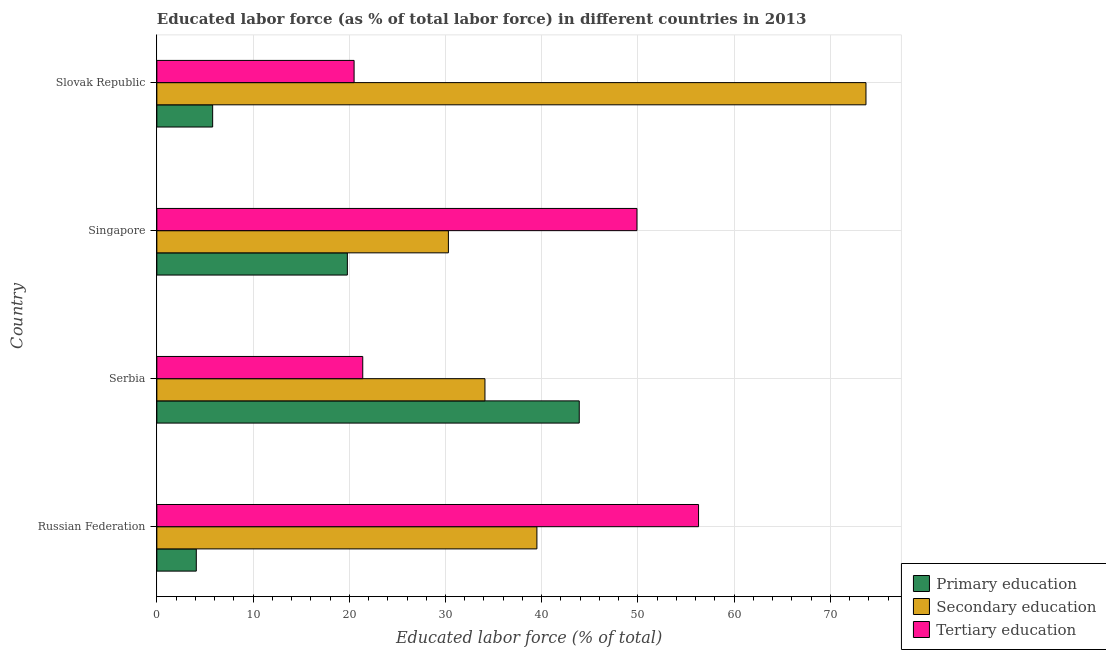How many groups of bars are there?
Provide a short and direct response. 4. How many bars are there on the 4th tick from the bottom?
Provide a succinct answer. 3. What is the label of the 2nd group of bars from the top?
Your answer should be very brief. Singapore. In how many cases, is the number of bars for a given country not equal to the number of legend labels?
Give a very brief answer. 0. What is the percentage of labor force who received primary education in Slovak Republic?
Your answer should be compact. 5.8. Across all countries, what is the maximum percentage of labor force who received tertiary education?
Offer a very short reply. 56.3. In which country was the percentage of labor force who received tertiary education maximum?
Ensure brevity in your answer.  Russian Federation. In which country was the percentage of labor force who received secondary education minimum?
Offer a terse response. Singapore. What is the total percentage of labor force who received primary education in the graph?
Your answer should be very brief. 73.6. What is the difference between the percentage of labor force who received primary education in Russian Federation and that in Serbia?
Keep it short and to the point. -39.8. What is the difference between the percentage of labor force who received primary education in Serbia and the percentage of labor force who received tertiary education in Russian Federation?
Your response must be concise. -12.4. What is the average percentage of labor force who received secondary education per country?
Keep it short and to the point. 44.4. What is the difference between the percentage of labor force who received tertiary education and percentage of labor force who received secondary education in Serbia?
Make the answer very short. -12.7. In how many countries, is the percentage of labor force who received primary education greater than 52 %?
Keep it short and to the point. 0. What is the ratio of the percentage of labor force who received primary education in Serbia to that in Slovak Republic?
Your answer should be very brief. 7.57. What is the difference between the highest and the second highest percentage of labor force who received secondary education?
Give a very brief answer. 34.2. What is the difference between the highest and the lowest percentage of labor force who received secondary education?
Provide a short and direct response. 43.4. Is the sum of the percentage of labor force who received tertiary education in Serbia and Slovak Republic greater than the maximum percentage of labor force who received secondary education across all countries?
Provide a short and direct response. No. What does the 3rd bar from the top in Russian Federation represents?
Provide a short and direct response. Primary education. What does the 2nd bar from the bottom in Singapore represents?
Give a very brief answer. Secondary education. Is it the case that in every country, the sum of the percentage of labor force who received primary education and percentage of labor force who received secondary education is greater than the percentage of labor force who received tertiary education?
Your answer should be very brief. No. How many bars are there?
Your answer should be compact. 12. Are all the bars in the graph horizontal?
Give a very brief answer. Yes. Does the graph contain grids?
Your answer should be compact. Yes. How many legend labels are there?
Provide a short and direct response. 3. What is the title of the graph?
Provide a succinct answer. Educated labor force (as % of total labor force) in different countries in 2013. What is the label or title of the X-axis?
Your response must be concise. Educated labor force (% of total). What is the Educated labor force (% of total) in Primary education in Russian Federation?
Ensure brevity in your answer.  4.1. What is the Educated labor force (% of total) in Secondary education in Russian Federation?
Provide a short and direct response. 39.5. What is the Educated labor force (% of total) in Tertiary education in Russian Federation?
Keep it short and to the point. 56.3. What is the Educated labor force (% of total) in Primary education in Serbia?
Offer a terse response. 43.9. What is the Educated labor force (% of total) of Secondary education in Serbia?
Your answer should be compact. 34.1. What is the Educated labor force (% of total) of Tertiary education in Serbia?
Provide a succinct answer. 21.4. What is the Educated labor force (% of total) of Primary education in Singapore?
Make the answer very short. 19.8. What is the Educated labor force (% of total) in Secondary education in Singapore?
Ensure brevity in your answer.  30.3. What is the Educated labor force (% of total) in Tertiary education in Singapore?
Your response must be concise. 49.9. What is the Educated labor force (% of total) in Primary education in Slovak Republic?
Your response must be concise. 5.8. What is the Educated labor force (% of total) of Secondary education in Slovak Republic?
Ensure brevity in your answer.  73.7. What is the Educated labor force (% of total) of Tertiary education in Slovak Republic?
Provide a succinct answer. 20.5. Across all countries, what is the maximum Educated labor force (% of total) of Primary education?
Make the answer very short. 43.9. Across all countries, what is the maximum Educated labor force (% of total) in Secondary education?
Provide a succinct answer. 73.7. Across all countries, what is the maximum Educated labor force (% of total) in Tertiary education?
Ensure brevity in your answer.  56.3. Across all countries, what is the minimum Educated labor force (% of total) in Primary education?
Keep it short and to the point. 4.1. Across all countries, what is the minimum Educated labor force (% of total) of Secondary education?
Your answer should be very brief. 30.3. Across all countries, what is the minimum Educated labor force (% of total) of Tertiary education?
Keep it short and to the point. 20.5. What is the total Educated labor force (% of total) of Primary education in the graph?
Your answer should be very brief. 73.6. What is the total Educated labor force (% of total) of Secondary education in the graph?
Your answer should be very brief. 177.6. What is the total Educated labor force (% of total) in Tertiary education in the graph?
Provide a short and direct response. 148.1. What is the difference between the Educated labor force (% of total) of Primary education in Russian Federation and that in Serbia?
Ensure brevity in your answer.  -39.8. What is the difference between the Educated labor force (% of total) of Secondary education in Russian Federation and that in Serbia?
Your response must be concise. 5.4. What is the difference between the Educated labor force (% of total) in Tertiary education in Russian Federation and that in Serbia?
Offer a very short reply. 34.9. What is the difference between the Educated labor force (% of total) in Primary education in Russian Federation and that in Singapore?
Your response must be concise. -15.7. What is the difference between the Educated labor force (% of total) in Secondary education in Russian Federation and that in Singapore?
Ensure brevity in your answer.  9.2. What is the difference between the Educated labor force (% of total) in Primary education in Russian Federation and that in Slovak Republic?
Give a very brief answer. -1.7. What is the difference between the Educated labor force (% of total) of Secondary education in Russian Federation and that in Slovak Republic?
Provide a short and direct response. -34.2. What is the difference between the Educated labor force (% of total) in Tertiary education in Russian Federation and that in Slovak Republic?
Your response must be concise. 35.8. What is the difference between the Educated labor force (% of total) of Primary education in Serbia and that in Singapore?
Keep it short and to the point. 24.1. What is the difference between the Educated labor force (% of total) of Secondary education in Serbia and that in Singapore?
Provide a succinct answer. 3.8. What is the difference between the Educated labor force (% of total) in Tertiary education in Serbia and that in Singapore?
Your answer should be very brief. -28.5. What is the difference between the Educated labor force (% of total) of Primary education in Serbia and that in Slovak Republic?
Your answer should be compact. 38.1. What is the difference between the Educated labor force (% of total) of Secondary education in Serbia and that in Slovak Republic?
Provide a succinct answer. -39.6. What is the difference between the Educated labor force (% of total) of Tertiary education in Serbia and that in Slovak Republic?
Your answer should be compact. 0.9. What is the difference between the Educated labor force (% of total) of Primary education in Singapore and that in Slovak Republic?
Your answer should be compact. 14. What is the difference between the Educated labor force (% of total) of Secondary education in Singapore and that in Slovak Republic?
Offer a terse response. -43.4. What is the difference between the Educated labor force (% of total) of Tertiary education in Singapore and that in Slovak Republic?
Give a very brief answer. 29.4. What is the difference between the Educated labor force (% of total) in Primary education in Russian Federation and the Educated labor force (% of total) in Tertiary education in Serbia?
Provide a short and direct response. -17.3. What is the difference between the Educated labor force (% of total) in Secondary education in Russian Federation and the Educated labor force (% of total) in Tertiary education in Serbia?
Make the answer very short. 18.1. What is the difference between the Educated labor force (% of total) in Primary education in Russian Federation and the Educated labor force (% of total) in Secondary education in Singapore?
Give a very brief answer. -26.2. What is the difference between the Educated labor force (% of total) of Primary education in Russian Federation and the Educated labor force (% of total) of Tertiary education in Singapore?
Your answer should be compact. -45.8. What is the difference between the Educated labor force (% of total) in Secondary education in Russian Federation and the Educated labor force (% of total) in Tertiary education in Singapore?
Offer a terse response. -10.4. What is the difference between the Educated labor force (% of total) of Primary education in Russian Federation and the Educated labor force (% of total) of Secondary education in Slovak Republic?
Offer a very short reply. -69.6. What is the difference between the Educated labor force (% of total) of Primary education in Russian Federation and the Educated labor force (% of total) of Tertiary education in Slovak Republic?
Your answer should be very brief. -16.4. What is the difference between the Educated labor force (% of total) in Primary education in Serbia and the Educated labor force (% of total) in Tertiary education in Singapore?
Make the answer very short. -6. What is the difference between the Educated labor force (% of total) of Secondary education in Serbia and the Educated labor force (% of total) of Tertiary education in Singapore?
Your response must be concise. -15.8. What is the difference between the Educated labor force (% of total) in Primary education in Serbia and the Educated labor force (% of total) in Secondary education in Slovak Republic?
Give a very brief answer. -29.8. What is the difference between the Educated labor force (% of total) of Primary education in Serbia and the Educated labor force (% of total) of Tertiary education in Slovak Republic?
Your answer should be compact. 23.4. What is the difference between the Educated labor force (% of total) of Secondary education in Serbia and the Educated labor force (% of total) of Tertiary education in Slovak Republic?
Make the answer very short. 13.6. What is the difference between the Educated labor force (% of total) in Primary education in Singapore and the Educated labor force (% of total) in Secondary education in Slovak Republic?
Ensure brevity in your answer.  -53.9. What is the difference between the Educated labor force (% of total) of Secondary education in Singapore and the Educated labor force (% of total) of Tertiary education in Slovak Republic?
Provide a short and direct response. 9.8. What is the average Educated labor force (% of total) of Primary education per country?
Provide a succinct answer. 18.4. What is the average Educated labor force (% of total) in Secondary education per country?
Ensure brevity in your answer.  44.4. What is the average Educated labor force (% of total) in Tertiary education per country?
Ensure brevity in your answer.  37.02. What is the difference between the Educated labor force (% of total) of Primary education and Educated labor force (% of total) of Secondary education in Russian Federation?
Your answer should be compact. -35.4. What is the difference between the Educated labor force (% of total) in Primary education and Educated labor force (% of total) in Tertiary education in Russian Federation?
Provide a succinct answer. -52.2. What is the difference between the Educated labor force (% of total) of Secondary education and Educated labor force (% of total) of Tertiary education in Russian Federation?
Provide a succinct answer. -16.8. What is the difference between the Educated labor force (% of total) of Primary education and Educated labor force (% of total) of Tertiary education in Serbia?
Make the answer very short. 22.5. What is the difference between the Educated labor force (% of total) of Secondary education and Educated labor force (% of total) of Tertiary education in Serbia?
Your response must be concise. 12.7. What is the difference between the Educated labor force (% of total) of Primary education and Educated labor force (% of total) of Tertiary education in Singapore?
Ensure brevity in your answer.  -30.1. What is the difference between the Educated labor force (% of total) in Secondary education and Educated labor force (% of total) in Tertiary education in Singapore?
Provide a short and direct response. -19.6. What is the difference between the Educated labor force (% of total) in Primary education and Educated labor force (% of total) in Secondary education in Slovak Republic?
Provide a succinct answer. -67.9. What is the difference between the Educated labor force (% of total) in Primary education and Educated labor force (% of total) in Tertiary education in Slovak Republic?
Provide a succinct answer. -14.7. What is the difference between the Educated labor force (% of total) of Secondary education and Educated labor force (% of total) of Tertiary education in Slovak Republic?
Ensure brevity in your answer.  53.2. What is the ratio of the Educated labor force (% of total) of Primary education in Russian Federation to that in Serbia?
Provide a short and direct response. 0.09. What is the ratio of the Educated labor force (% of total) in Secondary education in Russian Federation to that in Serbia?
Keep it short and to the point. 1.16. What is the ratio of the Educated labor force (% of total) of Tertiary education in Russian Federation to that in Serbia?
Make the answer very short. 2.63. What is the ratio of the Educated labor force (% of total) of Primary education in Russian Federation to that in Singapore?
Your response must be concise. 0.21. What is the ratio of the Educated labor force (% of total) of Secondary education in Russian Federation to that in Singapore?
Make the answer very short. 1.3. What is the ratio of the Educated labor force (% of total) of Tertiary education in Russian Federation to that in Singapore?
Provide a short and direct response. 1.13. What is the ratio of the Educated labor force (% of total) in Primary education in Russian Federation to that in Slovak Republic?
Your response must be concise. 0.71. What is the ratio of the Educated labor force (% of total) in Secondary education in Russian Federation to that in Slovak Republic?
Give a very brief answer. 0.54. What is the ratio of the Educated labor force (% of total) of Tertiary education in Russian Federation to that in Slovak Republic?
Your response must be concise. 2.75. What is the ratio of the Educated labor force (% of total) of Primary education in Serbia to that in Singapore?
Your answer should be compact. 2.22. What is the ratio of the Educated labor force (% of total) in Secondary education in Serbia to that in Singapore?
Keep it short and to the point. 1.13. What is the ratio of the Educated labor force (% of total) in Tertiary education in Serbia to that in Singapore?
Your answer should be compact. 0.43. What is the ratio of the Educated labor force (% of total) of Primary education in Serbia to that in Slovak Republic?
Keep it short and to the point. 7.57. What is the ratio of the Educated labor force (% of total) of Secondary education in Serbia to that in Slovak Republic?
Give a very brief answer. 0.46. What is the ratio of the Educated labor force (% of total) of Tertiary education in Serbia to that in Slovak Republic?
Make the answer very short. 1.04. What is the ratio of the Educated labor force (% of total) in Primary education in Singapore to that in Slovak Republic?
Offer a very short reply. 3.41. What is the ratio of the Educated labor force (% of total) of Secondary education in Singapore to that in Slovak Republic?
Offer a terse response. 0.41. What is the ratio of the Educated labor force (% of total) of Tertiary education in Singapore to that in Slovak Republic?
Your answer should be very brief. 2.43. What is the difference between the highest and the second highest Educated labor force (% of total) of Primary education?
Keep it short and to the point. 24.1. What is the difference between the highest and the second highest Educated labor force (% of total) in Secondary education?
Provide a succinct answer. 34.2. What is the difference between the highest and the second highest Educated labor force (% of total) in Tertiary education?
Your response must be concise. 6.4. What is the difference between the highest and the lowest Educated labor force (% of total) of Primary education?
Your answer should be very brief. 39.8. What is the difference between the highest and the lowest Educated labor force (% of total) in Secondary education?
Your answer should be very brief. 43.4. What is the difference between the highest and the lowest Educated labor force (% of total) of Tertiary education?
Your answer should be very brief. 35.8. 